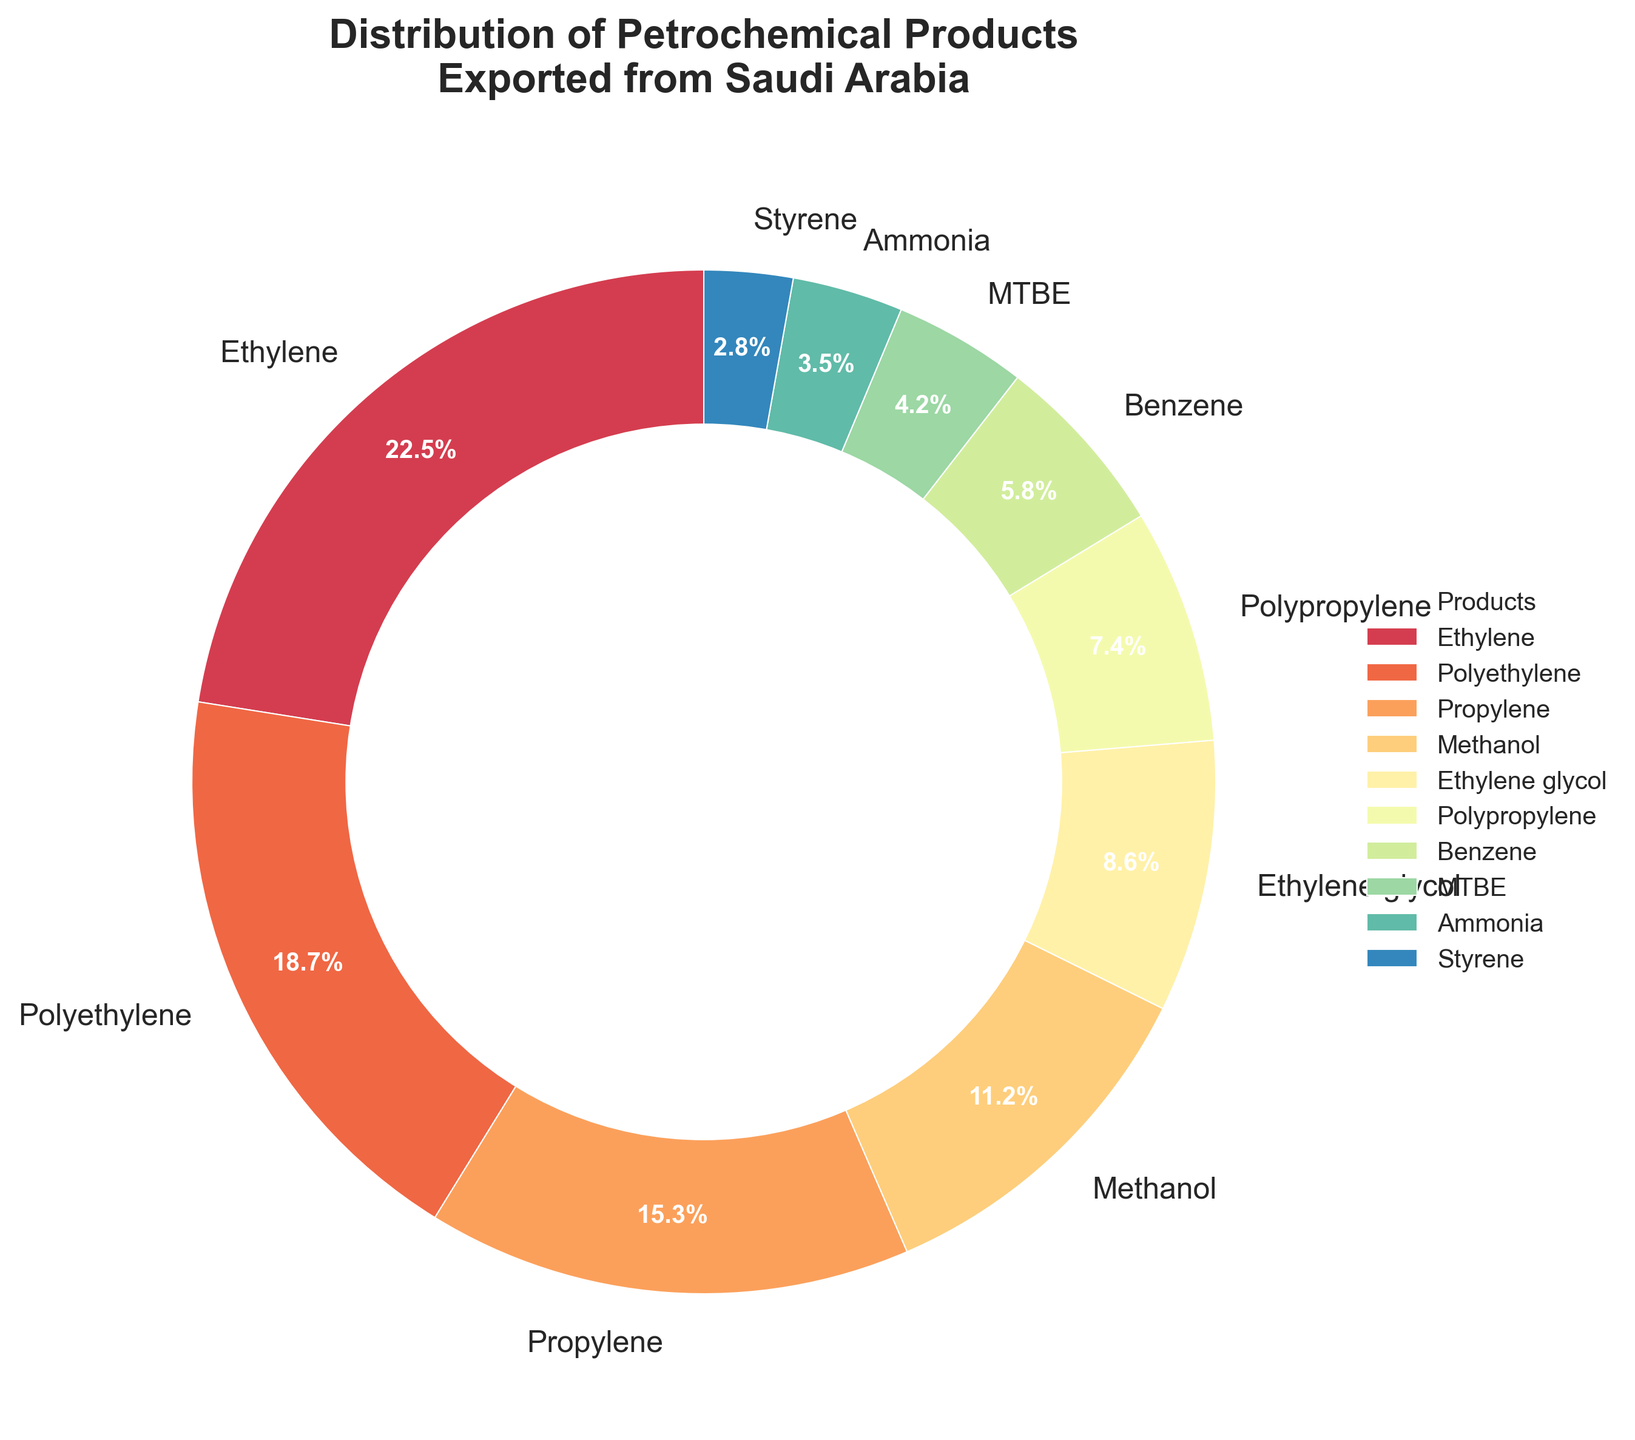What percentage of exports does Ethylene contribute? Ethylene's contribution can be directly read from the pie chart, which is labeled with the percentage information.
Answer: 22.5% Which product has the second highest percentage of exports? By looking at the pie chart, we can identify the product with the second largest slice after Ethylene. Polyethylene is the next largest slice.
Answer: Polyethylene What is the combined percentage of exports for Propylene and Methanol? Find the percentages for Propylene (15.3%) and Methanol (11.2%) and add them together: 15.3 + 11.2 = 26.5
Answer: 26.5% Is the percentage of Ammonia exports more or less than half of the Propylene exports? Compare the percentage of Ammonia (3.5%) to half of Propylene's percentage (15.3 / 2 = 7.65). Since 3.5 is less than 7.65, it's less.
Answer: Less What percentage do the smallest three categories (MTBE, Ammonia, and Styrene) make up together? Sum the percentages of MTBE (4.2%), Ammonia (3.5%), and Styrene (2.8%): 4.2 + 3.5 + 2.8 = 10.5
Answer: 10.5% How much greater is the percentage of Ethylene compared to Styrene? Subtract the percentage of Styrene (2.8%) from the percentage of Ethylene (22.5%): 22.5 - 2.8 = 19.7
Answer: 19.7% Which product has the smallest percentage of exports? The smallest slice in the pie chart corresponds to the product with the smallest export percentage, which is Styrene.
Answer: Styrene Are the combined percentages of Benzene and MTBE greater or less than that of Polyethylene? Find the combined percentage for Benzene (5.8%) and MTBE (4.2%): 5.8 + 4.2 = 10. Compare this to Polyethylene’s 18.7%. Since 10 is less than 18.7, it's less.
Answer: Less What is the average percentage contribution of Ethylene, Polyethylene, and Propylene? Add the percentages for Ethylene (22.5%), Polyethylene (18.7%), and Propylene (15.3%) and divide by 3: (22.5 + 18.7 + 15.3) / 3 = 56.5 / 3 = approx. 18.83
Answer: 18.83% Is the percentage of Ethylene glycol exports more or less than the combined percentage of Propylene and Methanol exports? Summing Propylene (15.3%) and Methanol (11.2%) gives 26.5%. Ethylene Glycol is 8.6%, which is less than 26.5%.
Answer: Less 